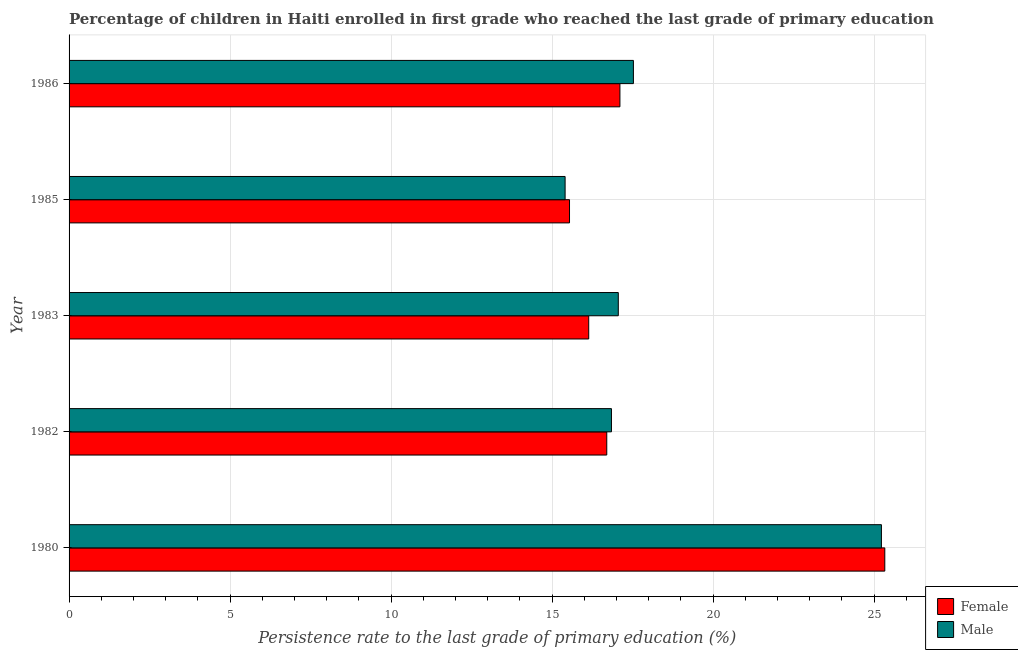How many different coloured bars are there?
Provide a succinct answer. 2. Are the number of bars per tick equal to the number of legend labels?
Offer a terse response. Yes. Are the number of bars on each tick of the Y-axis equal?
Give a very brief answer. Yes. How many bars are there on the 3rd tick from the top?
Ensure brevity in your answer.  2. How many bars are there on the 4th tick from the bottom?
Make the answer very short. 2. What is the label of the 4th group of bars from the top?
Ensure brevity in your answer.  1982. In how many cases, is the number of bars for a given year not equal to the number of legend labels?
Offer a terse response. 0. What is the persistence rate of male students in 1983?
Your response must be concise. 17.06. Across all years, what is the maximum persistence rate of female students?
Offer a terse response. 25.33. Across all years, what is the minimum persistence rate of female students?
Ensure brevity in your answer.  15.54. What is the total persistence rate of female students in the graph?
Ensure brevity in your answer.  90.82. What is the difference between the persistence rate of female students in 1985 and that in 1986?
Offer a terse response. -1.56. What is the difference between the persistence rate of male students in 1985 and the persistence rate of female students in 1986?
Give a very brief answer. -1.7. What is the average persistence rate of male students per year?
Offer a terse response. 18.41. In the year 1986, what is the difference between the persistence rate of female students and persistence rate of male students?
Provide a short and direct response. -0.42. In how many years, is the persistence rate of female students greater than 2 %?
Ensure brevity in your answer.  5. What is the ratio of the persistence rate of female students in 1983 to that in 1985?
Make the answer very short. 1.04. Is the persistence rate of male students in 1982 less than that in 1983?
Offer a terse response. Yes. What is the difference between the highest and the second highest persistence rate of female students?
Give a very brief answer. 8.23. What is the difference between the highest and the lowest persistence rate of female students?
Offer a very short reply. 9.79. What does the 1st bar from the top in 1983 represents?
Your answer should be compact. Male. What does the 1st bar from the bottom in 1982 represents?
Ensure brevity in your answer.  Female. Are all the bars in the graph horizontal?
Offer a terse response. Yes. How many years are there in the graph?
Provide a succinct answer. 5. How many legend labels are there?
Your answer should be very brief. 2. What is the title of the graph?
Ensure brevity in your answer.  Percentage of children in Haiti enrolled in first grade who reached the last grade of primary education. Does "IMF concessional" appear as one of the legend labels in the graph?
Provide a succinct answer. No. What is the label or title of the X-axis?
Give a very brief answer. Persistence rate to the last grade of primary education (%). What is the Persistence rate to the last grade of primary education (%) in Female in 1980?
Offer a very short reply. 25.33. What is the Persistence rate to the last grade of primary education (%) in Male in 1980?
Provide a short and direct response. 25.23. What is the Persistence rate to the last grade of primary education (%) in Female in 1982?
Provide a short and direct response. 16.7. What is the Persistence rate to the last grade of primary education (%) of Male in 1982?
Ensure brevity in your answer.  16.84. What is the Persistence rate to the last grade of primary education (%) of Female in 1983?
Keep it short and to the point. 16.14. What is the Persistence rate to the last grade of primary education (%) in Male in 1983?
Ensure brevity in your answer.  17.06. What is the Persistence rate to the last grade of primary education (%) in Female in 1985?
Offer a very short reply. 15.54. What is the Persistence rate to the last grade of primary education (%) in Male in 1985?
Offer a terse response. 15.41. What is the Persistence rate to the last grade of primary education (%) in Female in 1986?
Give a very brief answer. 17.11. What is the Persistence rate to the last grade of primary education (%) of Male in 1986?
Your answer should be compact. 17.53. Across all years, what is the maximum Persistence rate to the last grade of primary education (%) of Female?
Ensure brevity in your answer.  25.33. Across all years, what is the maximum Persistence rate to the last grade of primary education (%) in Male?
Ensure brevity in your answer.  25.23. Across all years, what is the minimum Persistence rate to the last grade of primary education (%) of Female?
Ensure brevity in your answer.  15.54. Across all years, what is the minimum Persistence rate to the last grade of primary education (%) in Male?
Provide a short and direct response. 15.41. What is the total Persistence rate to the last grade of primary education (%) in Female in the graph?
Provide a succinct answer. 90.82. What is the total Persistence rate to the last grade of primary education (%) of Male in the graph?
Offer a terse response. 92.06. What is the difference between the Persistence rate to the last grade of primary education (%) of Female in 1980 and that in 1982?
Ensure brevity in your answer.  8.63. What is the difference between the Persistence rate to the last grade of primary education (%) of Male in 1980 and that in 1982?
Provide a short and direct response. 8.38. What is the difference between the Persistence rate to the last grade of primary education (%) in Female in 1980 and that in 1983?
Your answer should be compact. 9.2. What is the difference between the Persistence rate to the last grade of primary education (%) of Male in 1980 and that in 1983?
Your answer should be compact. 8.17. What is the difference between the Persistence rate to the last grade of primary education (%) of Female in 1980 and that in 1985?
Offer a very short reply. 9.79. What is the difference between the Persistence rate to the last grade of primary education (%) of Male in 1980 and that in 1985?
Your response must be concise. 9.82. What is the difference between the Persistence rate to the last grade of primary education (%) in Female in 1980 and that in 1986?
Offer a terse response. 8.23. What is the difference between the Persistence rate to the last grade of primary education (%) in Male in 1980 and that in 1986?
Make the answer very short. 7.7. What is the difference between the Persistence rate to the last grade of primary education (%) of Female in 1982 and that in 1983?
Provide a succinct answer. 0.56. What is the difference between the Persistence rate to the last grade of primary education (%) in Male in 1982 and that in 1983?
Give a very brief answer. -0.21. What is the difference between the Persistence rate to the last grade of primary education (%) of Female in 1982 and that in 1985?
Offer a very short reply. 1.16. What is the difference between the Persistence rate to the last grade of primary education (%) of Male in 1982 and that in 1985?
Keep it short and to the point. 1.44. What is the difference between the Persistence rate to the last grade of primary education (%) in Female in 1982 and that in 1986?
Offer a terse response. -0.41. What is the difference between the Persistence rate to the last grade of primary education (%) of Male in 1982 and that in 1986?
Offer a terse response. -0.68. What is the difference between the Persistence rate to the last grade of primary education (%) in Female in 1983 and that in 1985?
Offer a very short reply. 0.6. What is the difference between the Persistence rate to the last grade of primary education (%) of Male in 1983 and that in 1985?
Provide a succinct answer. 1.65. What is the difference between the Persistence rate to the last grade of primary education (%) in Female in 1983 and that in 1986?
Your answer should be very brief. -0.97. What is the difference between the Persistence rate to the last grade of primary education (%) in Male in 1983 and that in 1986?
Provide a succinct answer. -0.47. What is the difference between the Persistence rate to the last grade of primary education (%) in Female in 1985 and that in 1986?
Keep it short and to the point. -1.57. What is the difference between the Persistence rate to the last grade of primary education (%) in Male in 1985 and that in 1986?
Keep it short and to the point. -2.12. What is the difference between the Persistence rate to the last grade of primary education (%) in Female in 1980 and the Persistence rate to the last grade of primary education (%) in Male in 1982?
Your answer should be very brief. 8.49. What is the difference between the Persistence rate to the last grade of primary education (%) in Female in 1980 and the Persistence rate to the last grade of primary education (%) in Male in 1983?
Your answer should be very brief. 8.28. What is the difference between the Persistence rate to the last grade of primary education (%) of Female in 1980 and the Persistence rate to the last grade of primary education (%) of Male in 1985?
Make the answer very short. 9.93. What is the difference between the Persistence rate to the last grade of primary education (%) of Female in 1980 and the Persistence rate to the last grade of primary education (%) of Male in 1986?
Your answer should be very brief. 7.81. What is the difference between the Persistence rate to the last grade of primary education (%) in Female in 1982 and the Persistence rate to the last grade of primary education (%) in Male in 1983?
Provide a succinct answer. -0.36. What is the difference between the Persistence rate to the last grade of primary education (%) of Female in 1982 and the Persistence rate to the last grade of primary education (%) of Male in 1985?
Your answer should be compact. 1.29. What is the difference between the Persistence rate to the last grade of primary education (%) of Female in 1982 and the Persistence rate to the last grade of primary education (%) of Male in 1986?
Ensure brevity in your answer.  -0.83. What is the difference between the Persistence rate to the last grade of primary education (%) in Female in 1983 and the Persistence rate to the last grade of primary education (%) in Male in 1985?
Offer a very short reply. 0.73. What is the difference between the Persistence rate to the last grade of primary education (%) of Female in 1983 and the Persistence rate to the last grade of primary education (%) of Male in 1986?
Your answer should be compact. -1.39. What is the difference between the Persistence rate to the last grade of primary education (%) of Female in 1985 and the Persistence rate to the last grade of primary education (%) of Male in 1986?
Your response must be concise. -1.98. What is the average Persistence rate to the last grade of primary education (%) in Female per year?
Offer a terse response. 18.16. What is the average Persistence rate to the last grade of primary education (%) of Male per year?
Your response must be concise. 18.41. In the year 1980, what is the difference between the Persistence rate to the last grade of primary education (%) in Female and Persistence rate to the last grade of primary education (%) in Male?
Keep it short and to the point. 0.11. In the year 1982, what is the difference between the Persistence rate to the last grade of primary education (%) in Female and Persistence rate to the last grade of primary education (%) in Male?
Offer a very short reply. -0.15. In the year 1983, what is the difference between the Persistence rate to the last grade of primary education (%) in Female and Persistence rate to the last grade of primary education (%) in Male?
Provide a short and direct response. -0.92. In the year 1985, what is the difference between the Persistence rate to the last grade of primary education (%) in Female and Persistence rate to the last grade of primary education (%) in Male?
Your answer should be compact. 0.14. In the year 1986, what is the difference between the Persistence rate to the last grade of primary education (%) in Female and Persistence rate to the last grade of primary education (%) in Male?
Make the answer very short. -0.42. What is the ratio of the Persistence rate to the last grade of primary education (%) in Female in 1980 to that in 1982?
Offer a terse response. 1.52. What is the ratio of the Persistence rate to the last grade of primary education (%) in Male in 1980 to that in 1982?
Make the answer very short. 1.5. What is the ratio of the Persistence rate to the last grade of primary education (%) in Female in 1980 to that in 1983?
Offer a terse response. 1.57. What is the ratio of the Persistence rate to the last grade of primary education (%) in Male in 1980 to that in 1983?
Your response must be concise. 1.48. What is the ratio of the Persistence rate to the last grade of primary education (%) of Female in 1980 to that in 1985?
Offer a very short reply. 1.63. What is the ratio of the Persistence rate to the last grade of primary education (%) of Male in 1980 to that in 1985?
Provide a short and direct response. 1.64. What is the ratio of the Persistence rate to the last grade of primary education (%) in Female in 1980 to that in 1986?
Ensure brevity in your answer.  1.48. What is the ratio of the Persistence rate to the last grade of primary education (%) in Male in 1980 to that in 1986?
Give a very brief answer. 1.44. What is the ratio of the Persistence rate to the last grade of primary education (%) in Female in 1982 to that in 1983?
Make the answer very short. 1.03. What is the ratio of the Persistence rate to the last grade of primary education (%) of Male in 1982 to that in 1983?
Give a very brief answer. 0.99. What is the ratio of the Persistence rate to the last grade of primary education (%) in Female in 1982 to that in 1985?
Give a very brief answer. 1.07. What is the ratio of the Persistence rate to the last grade of primary education (%) in Male in 1982 to that in 1985?
Offer a very short reply. 1.09. What is the ratio of the Persistence rate to the last grade of primary education (%) in Female in 1982 to that in 1986?
Provide a short and direct response. 0.98. What is the ratio of the Persistence rate to the last grade of primary education (%) in Male in 1982 to that in 1986?
Give a very brief answer. 0.96. What is the ratio of the Persistence rate to the last grade of primary education (%) in Female in 1983 to that in 1985?
Ensure brevity in your answer.  1.04. What is the ratio of the Persistence rate to the last grade of primary education (%) in Male in 1983 to that in 1985?
Ensure brevity in your answer.  1.11. What is the ratio of the Persistence rate to the last grade of primary education (%) in Female in 1983 to that in 1986?
Your answer should be very brief. 0.94. What is the ratio of the Persistence rate to the last grade of primary education (%) in Male in 1983 to that in 1986?
Offer a very short reply. 0.97. What is the ratio of the Persistence rate to the last grade of primary education (%) in Female in 1985 to that in 1986?
Keep it short and to the point. 0.91. What is the ratio of the Persistence rate to the last grade of primary education (%) in Male in 1985 to that in 1986?
Give a very brief answer. 0.88. What is the difference between the highest and the second highest Persistence rate to the last grade of primary education (%) in Female?
Provide a short and direct response. 8.23. What is the difference between the highest and the second highest Persistence rate to the last grade of primary education (%) in Male?
Provide a succinct answer. 7.7. What is the difference between the highest and the lowest Persistence rate to the last grade of primary education (%) in Female?
Provide a succinct answer. 9.79. What is the difference between the highest and the lowest Persistence rate to the last grade of primary education (%) in Male?
Provide a succinct answer. 9.82. 